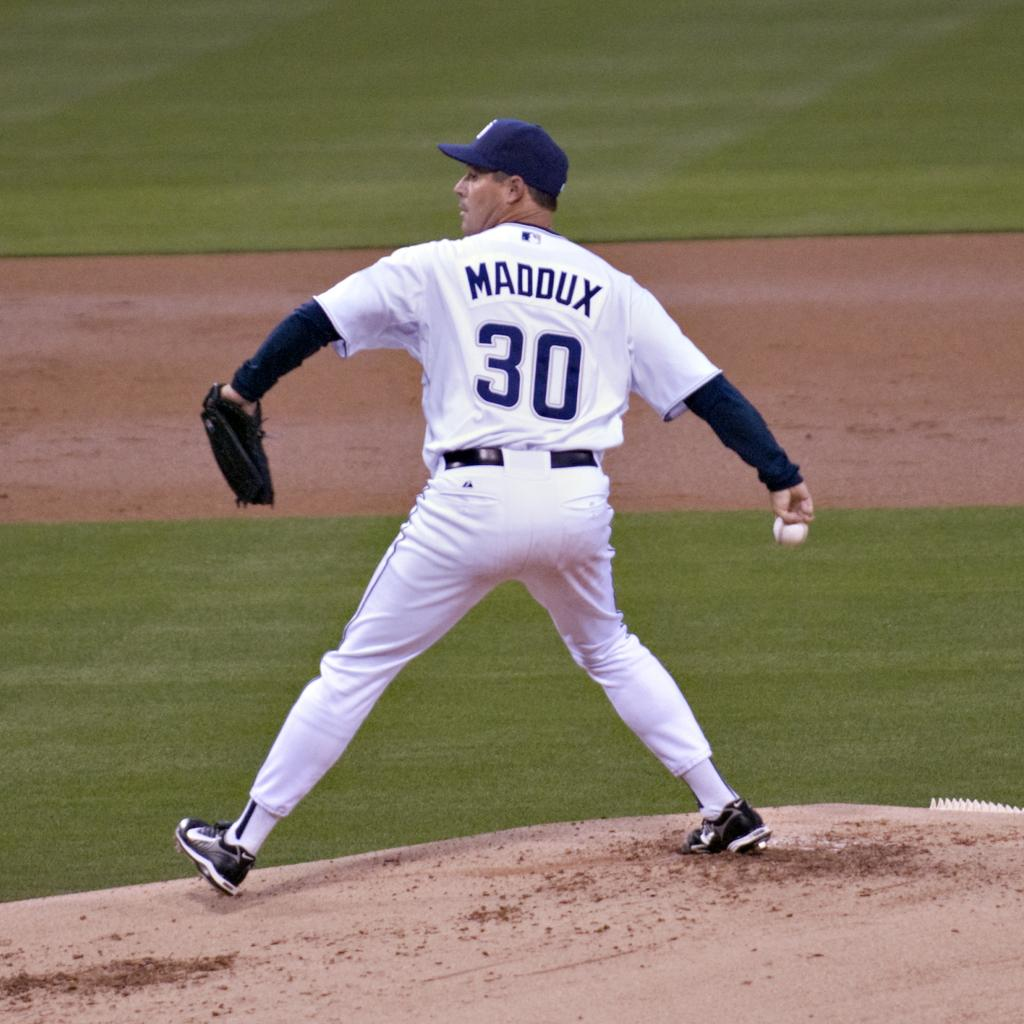<image>
Summarize the visual content of the image. a man in a baseball uniform that says maddux #30 winds up his arm to throw a baseball 